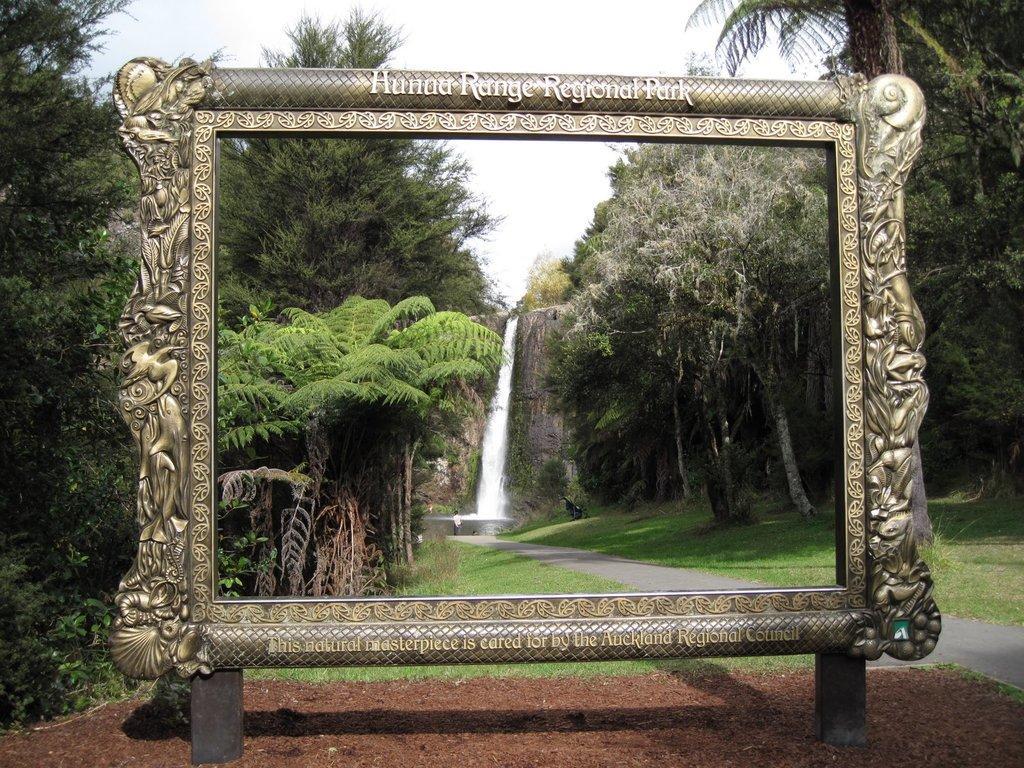Could you give a brief overview of what you see in this image? In the image we can see the frame and text on it. Here we can see waterfalls, grass and trees. We can even see a person standing wearing clothes, road and the sky. 